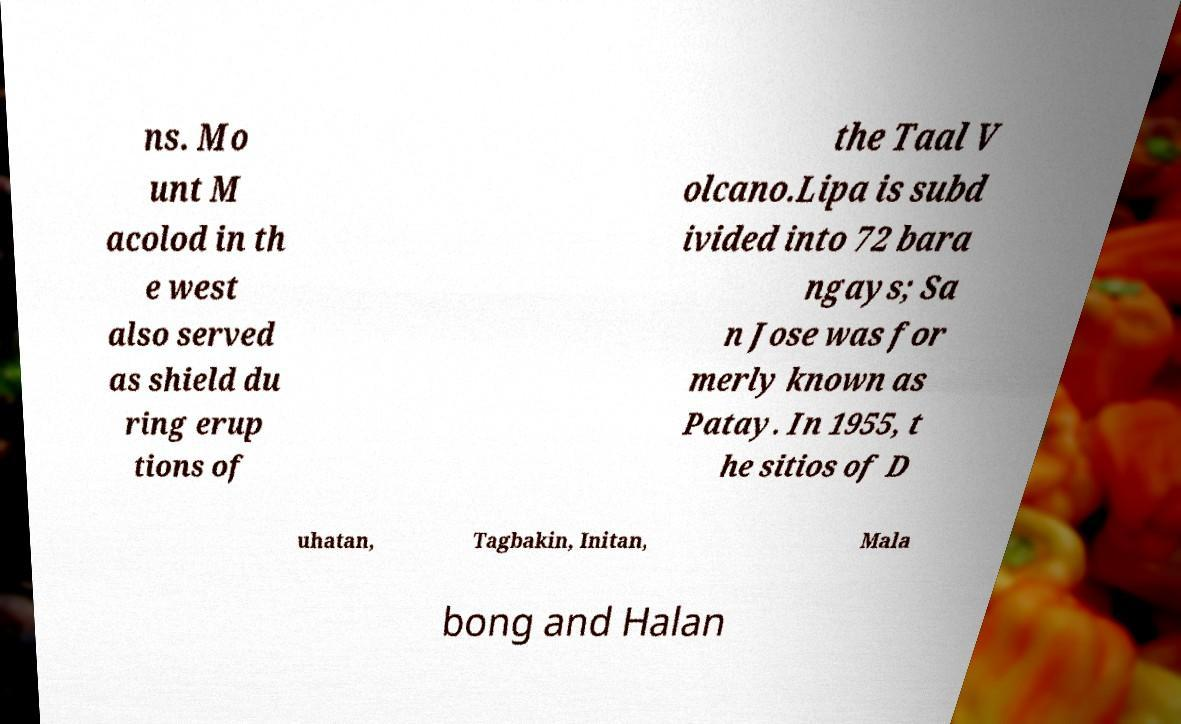Please identify and transcribe the text found in this image. ns. Mo unt M acolod in th e west also served as shield du ring erup tions of the Taal V olcano.Lipa is subd ivided into 72 bara ngays; Sa n Jose was for merly known as Patay. In 1955, t he sitios of D uhatan, Tagbakin, Initan, Mala bong and Halan 